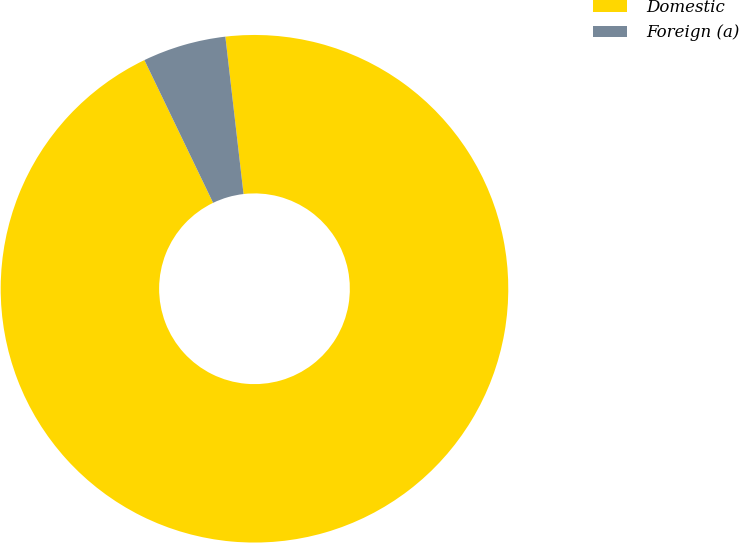<chart> <loc_0><loc_0><loc_500><loc_500><pie_chart><fcel>Domestic<fcel>Foreign (a)<nl><fcel>94.69%<fcel>5.31%<nl></chart> 